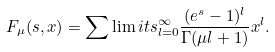Convert formula to latex. <formula><loc_0><loc_0><loc_500><loc_500>F _ { \mu } ( s , x ) = \sum \lim i t s _ { l = 0 } ^ { \infty } \frac { ( e ^ { s } - 1 ) ^ { l } } { \Gamma ( \mu l + 1 ) } x ^ { l } .</formula> 